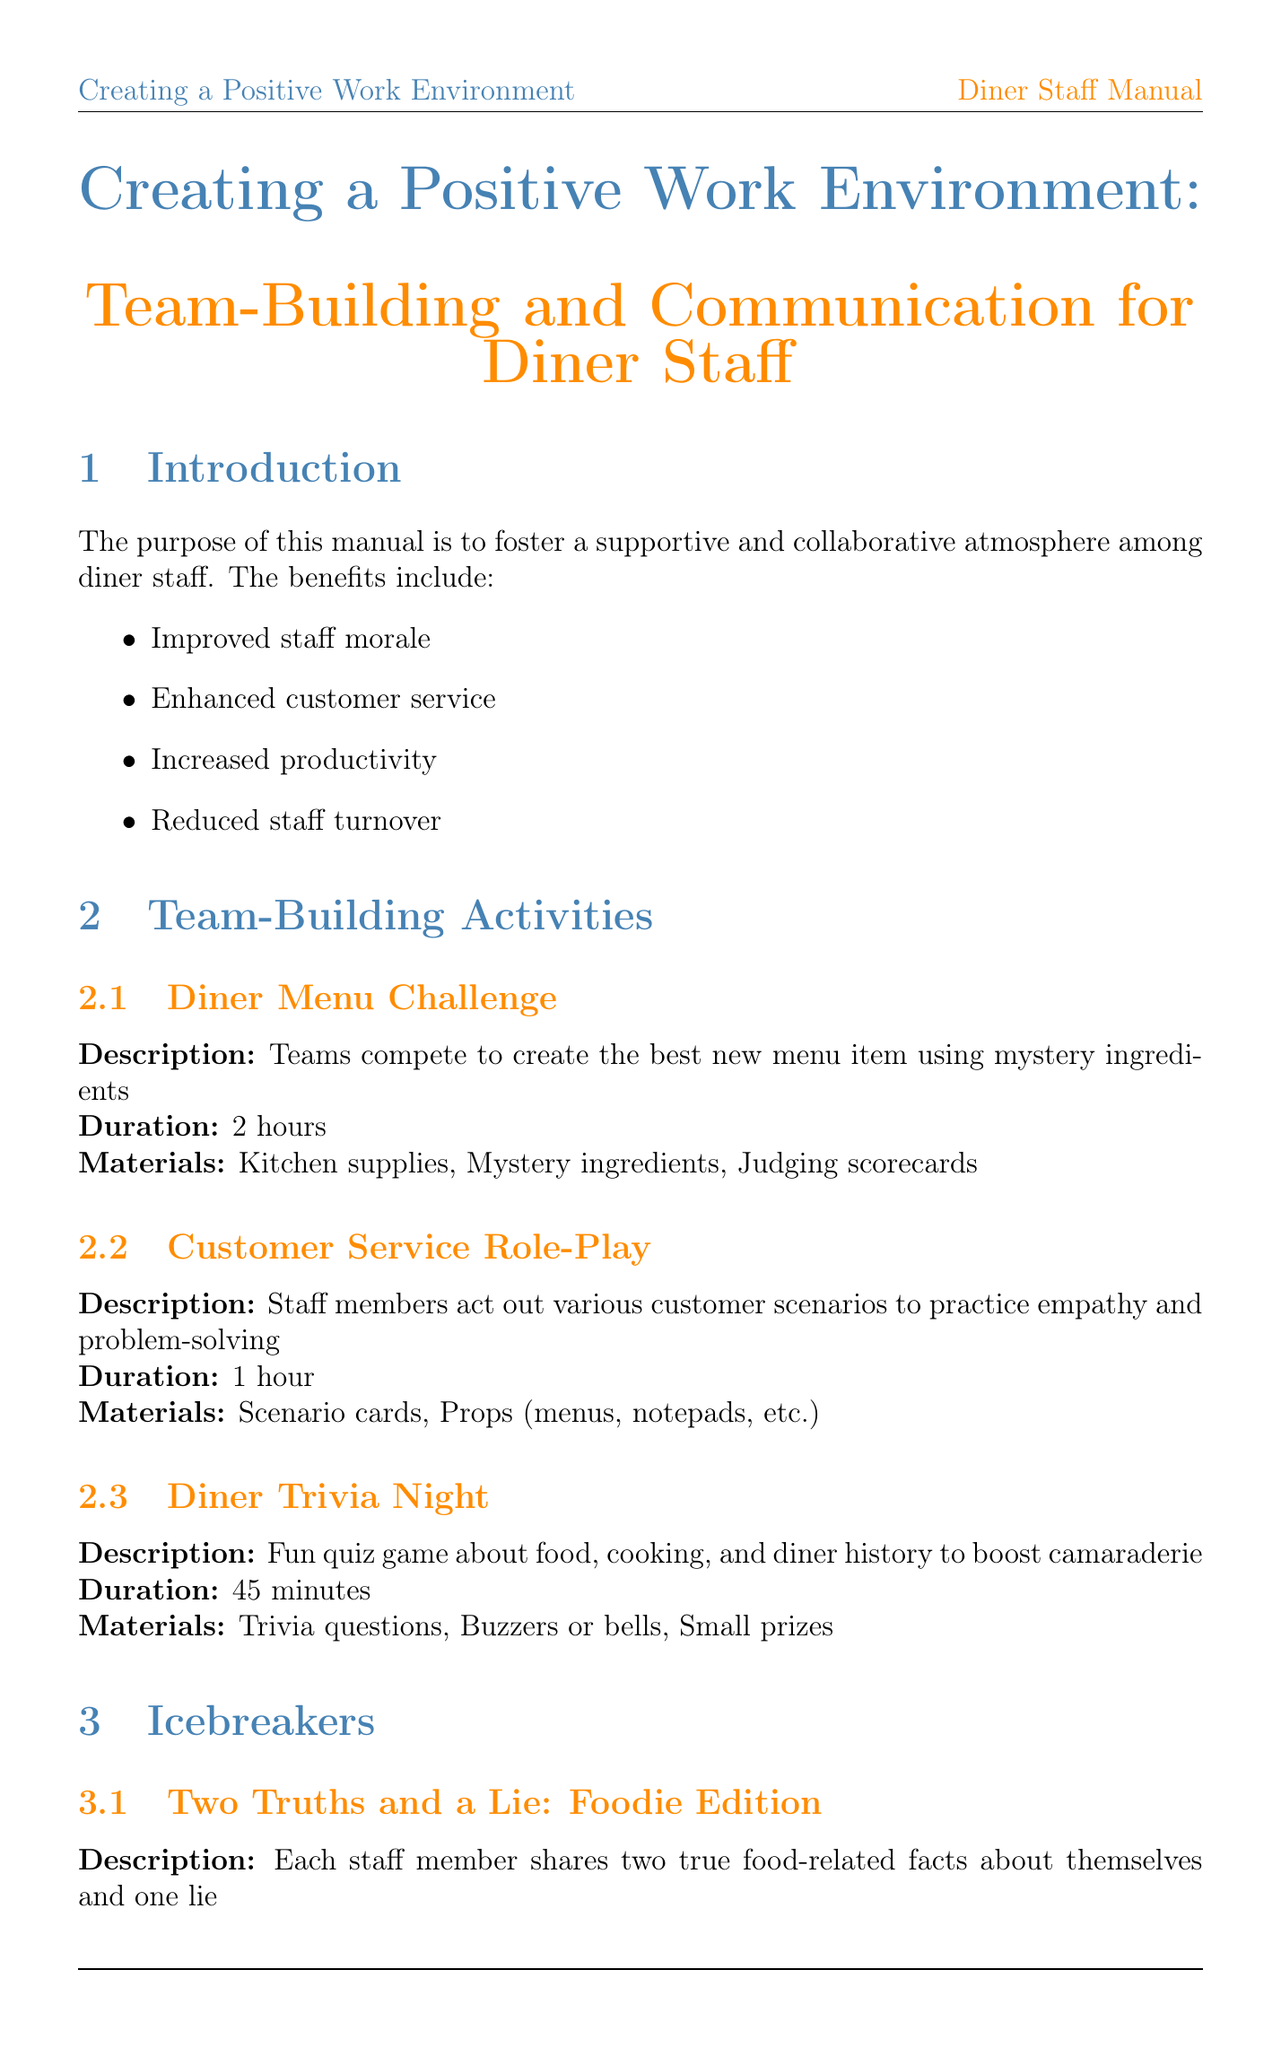What is the title of the manual? The title of the manual is indicated at the beginning and is "Creating a Positive Work Environment: Team-Building and Communication for Diner Staff."
Answer: Creating a Positive Work Environment: Team-Building and Communication for Diner Staff How long is the Diner Menu Challenge activity? The duration of the Diner Menu Challenge activity is specified in the team-building activities section.
Answer: 2 hours What is the purpose of the anonymous suggestion box? The purpose of the anonymous suggestion box is detailed in the communication strategies section, which states it allows staff to provide feedback and ideas without fear of judgment.
Answer: Feedback and ideas How often is the Employee of the Month recognized? The frequency of the Employee of the Month recognition is mentioned in the recognition and rewards section.
Answer: Monthly What is the group size for the Favorite Meal Memory icebreaker? The group size for the Favorite Meal Memory icebreaker is specifically mentioned in the icebreakers section.
Answer: 5-10 people What is one strategy to resolve conflict? The document outlines steps for conflict resolution, one of which is to listen to all parties involved.
Answer: Listen to all parties What is the main benefit of implementing team-building activities? The main benefit stated in the introduction of the manual is improved staff morale, which is one of the listed benefits.
Answer: Improved staff morale What duration is allocated for the Daily Pre-Shift Huddle? The duration of the Daily Pre-Shift Huddle is provided in the communication strategies section.
Answer: 10 minutes What happens during the Team Goal Celebration? The Team Goal Celebration is described in terms of the activity that occurs when team goals are achieved, focusing on celebrating with a special staff meal or outing.
Answer: Special staff meal or outing 